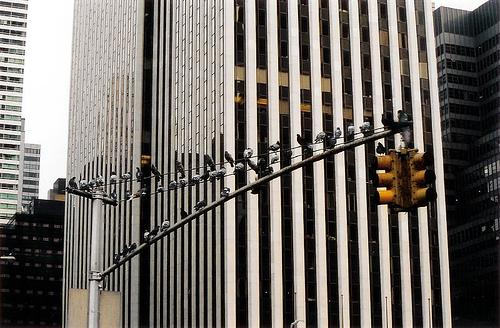What are the birds perched on? stoplight 